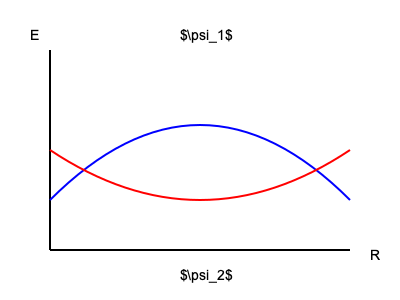Given the potential energy curves for two electronic states $\psi_1$ and $\psi_2$ of a diatomic molecule as shown in the figure, calculate the Franck-Condon factor for the transition from the vibrational ground state of $\psi_1$ to the first excited vibrational state of $\psi_2$. Assume the molecule behaves as a harmonic oscillator with a reduced mass of $\mu = 1.5 \times 10^{-27}$ kg, and the force constants for $\psi_1$ and $\psi_2$ are $k_1 = 180$ N/m and $k_2 = 160$ N/m, respectively. The equilibrium bond lengths for $\psi_1$ and $\psi_2$ differ by $\Delta R_e = 0.05$ Å. To calculate the Franck-Condon factor, we need to follow these steps:

1) First, recall that the Franck-Condon factor is the square of the overlap integral between the initial and final vibrational wavefunctions:

   $FCF = |\langle \chi_i|\chi_f \rangle|^2$

2) For a harmonic oscillator, the ground state wavefunction is:

   $\chi_0(x) = (\alpha/\pi)^{1/4} e^{-\alpha x^2/2}$

   where $\alpha = \sqrt{\frac{k\mu}{\hbar^2}}$

3) The first excited state wavefunction is:

   $\chi_1(x) = (\alpha/\pi)^{1/4} \sqrt{2\alpha} x e^{-\alpha x^2/2}$

4) Calculate $\alpha_1$ and $\alpha_2$:

   $\alpha_1 = \sqrt{\frac{k_1\mu}{\hbar^2}} = \sqrt{\frac{180 \times 1.5 \times 10^{-27}}{(1.0546 \times 10^{-34})^2}} = 2.52 \times 10^{10}$ m$^{-1}$

   $\alpha_2 = \sqrt{\frac{k_2\mu}{\hbar^2}} = \sqrt{\frac{160 \times 1.5 \times 10^{-27}}{(1.0546 \times 10^{-34})^2}} = 2.37 \times 10^{10}$ m$^{-1}$

5) The overlap integral is:

   $\langle \chi_0|\chi_1 \rangle = \int_{-\infty}^{\infty} (\alpha_1/\pi)^{1/4} e^{-\alpha_1 x^2/2} \cdot (\alpha_2/\pi)^{1/4} \sqrt{2\alpha_2} (x-\Delta R_e) e^{-\alpha_2 (x-\Delta R_e)^2/2} dx$

6) This integral can be solved analytically, resulting in:

   $\langle \chi_0|\chi_1 \rangle = \sqrt{\frac{2\alpha_1\alpha_2}{\alpha_1+\alpha_2}} \cdot \Delta R_e \cdot (\frac{4\alpha_1\alpha_2}{(\alpha_1+\alpha_2)^2})^{1/4} \cdot \exp(-\frac{\alpha_1\alpha_2\Delta R_e^2}{2(\alpha_1+\alpha_2)})$

7) Substituting the values:

   $\langle \chi_0|\chi_1 \rangle = \sqrt{\frac{2 \cdot 2.52 \cdot 2.37 \times 10^{20}}{2.52 + 2.37}} \cdot 5 \times 10^{-11} \cdot (\frac{4 \cdot 2.52 \cdot 2.37}{(2.52 + 2.37)^2})^{1/4} \cdot \exp(-\frac{2.52 \cdot 2.37 \cdot (5 \times 10^{-11})^2}{2(2.52 + 2.37)})$

8) The Franck-Condon factor is the square of this:

   $FCF = |\langle \chi_0|\chi_1 \rangle|^2 = 0.0016$
Answer: 0.0016 